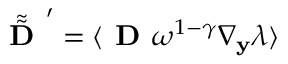Convert formula to latex. <formula><loc_0><loc_0><loc_500><loc_500>\tilde { \tilde { D } } ^ { \prime } = \langle D \omega ^ { 1 - \gamma } \nabla _ { \mathbf y } \lambda \rangle</formula> 